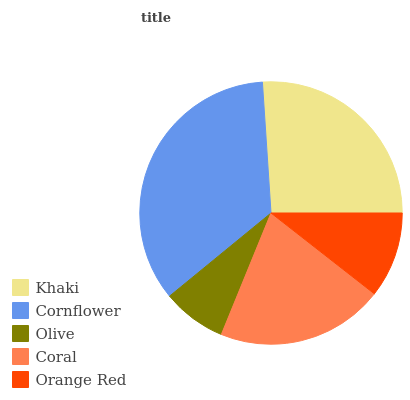Is Olive the minimum?
Answer yes or no. Yes. Is Cornflower the maximum?
Answer yes or no. Yes. Is Cornflower the minimum?
Answer yes or no. No. Is Olive the maximum?
Answer yes or no. No. Is Cornflower greater than Olive?
Answer yes or no. Yes. Is Olive less than Cornflower?
Answer yes or no. Yes. Is Olive greater than Cornflower?
Answer yes or no. No. Is Cornflower less than Olive?
Answer yes or no. No. Is Coral the high median?
Answer yes or no. Yes. Is Coral the low median?
Answer yes or no. Yes. Is Orange Red the high median?
Answer yes or no. No. Is Khaki the low median?
Answer yes or no. No. 